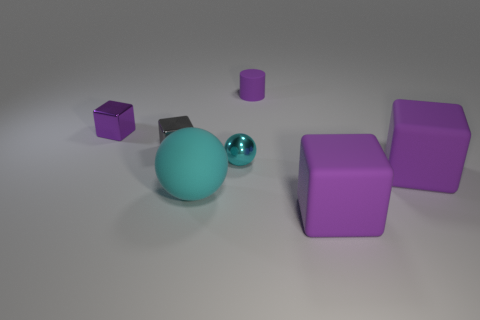Subtract all purple cubes. How many were subtracted if there are1purple cubes left? 2 Subtract all purple cylinders. How many purple blocks are left? 3 Add 1 big purple shiny blocks. How many objects exist? 8 Subtract all spheres. How many objects are left? 5 Add 6 large spheres. How many large spheres are left? 7 Add 5 big blue matte cylinders. How many big blue matte cylinders exist? 5 Subtract 0 cyan cubes. How many objects are left? 7 Subtract all big purple things. Subtract all big purple rubber things. How many objects are left? 3 